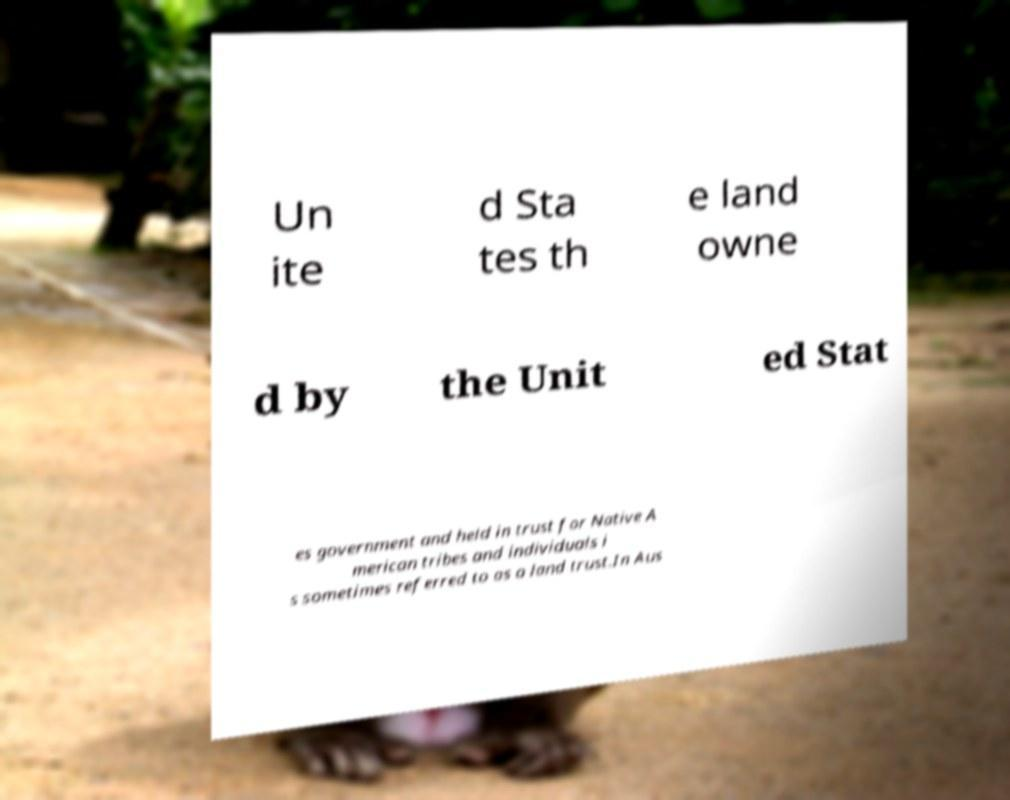I need the written content from this picture converted into text. Can you do that? Un ite d Sta tes th e land owne d by the Unit ed Stat es government and held in trust for Native A merican tribes and individuals i s sometimes referred to as a land trust.In Aus 